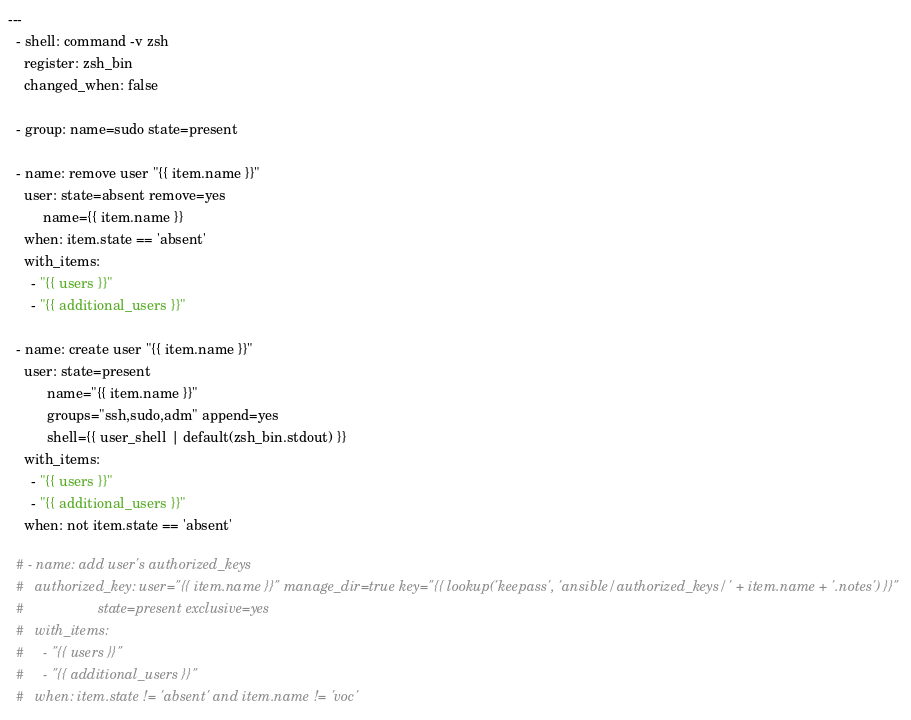<code> <loc_0><loc_0><loc_500><loc_500><_YAML_>---
  - shell: command -v zsh
    register: zsh_bin
    changed_when: false

  - group: name=sudo state=present

  - name: remove user "{{ item.name }}"
    user: state=absent remove=yes
         name={{ item.name }}
    when: item.state == 'absent'
    with_items:
      - "{{ users }}"
      - "{{ additional_users }}"

  - name: create user "{{ item.name }}"
    user: state=present
          name="{{ item.name }}"
          groups="ssh,sudo,adm" append=yes
          shell={{ user_shell | default(zsh_bin.stdout) }}
    with_items:
      - "{{ users }}"
      - "{{ additional_users }}"
    when: not item.state == 'absent'

  # - name: add user's authorized_keys
  #   authorized_key: user="{{ item.name }}" manage_dir=true key="{{ lookup('keepass', 'ansible/authorized_keys/' + item.name + '.notes') }}"
  #                   state=present exclusive=yes
  #   with_items:
  #     - "{{ users }}"
  #     - "{{ additional_users }}"
  #   when: item.state != 'absent' and item.name != 'voc'

</code> 